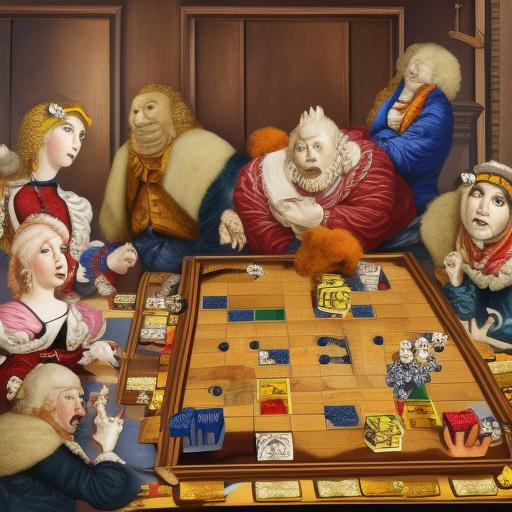What do the facial expressions of the characters tell us about the game of chess? The facial expressions offer a rich narrative about the intensity and emotional investment in the chess game. Some characters exhibit a deep concentration, with furrowed brows and eyes locked on the chessboard, while others seem to react with amusement or curiosity. These varied expressions reflect the intellectual challenge and the dynamic social interactions that the game of chess can provoke. 